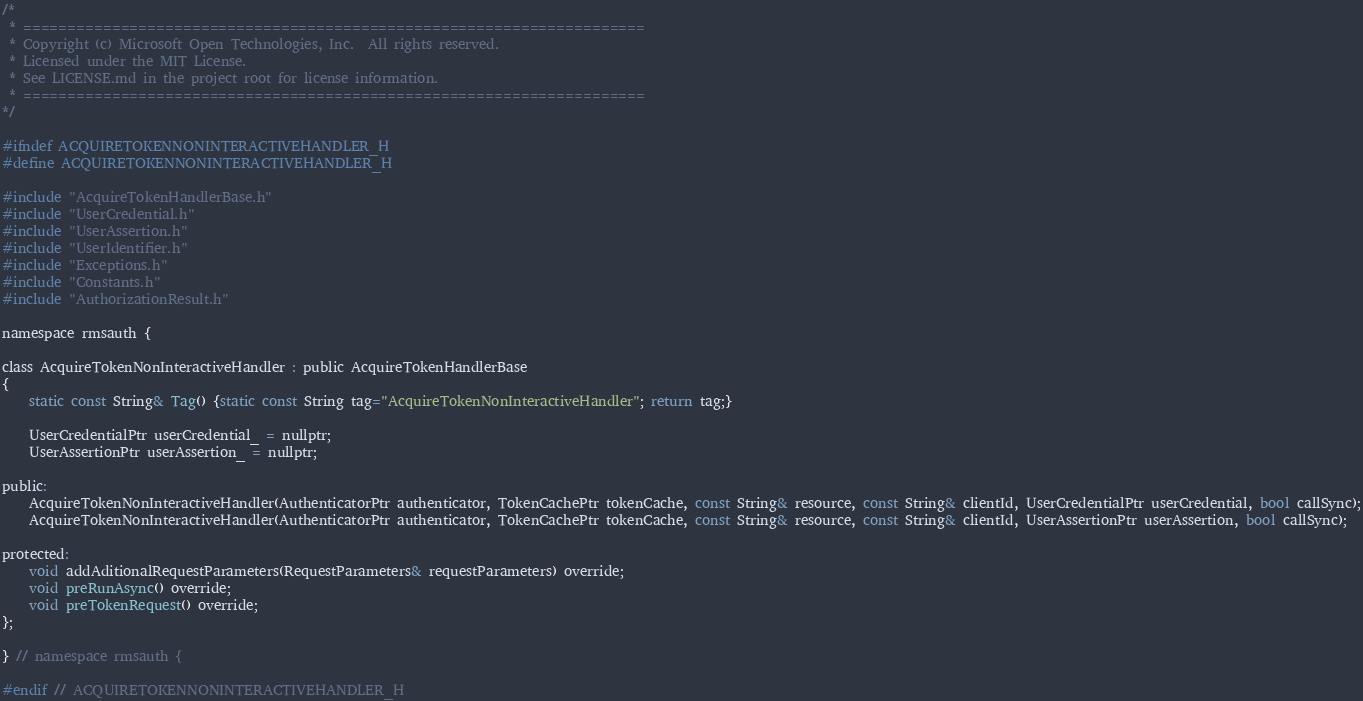<code> <loc_0><loc_0><loc_500><loc_500><_C_>/*
 * ======================================================================
 * Copyright (c) Microsoft Open Technologies, Inc.  All rights reserved.
 * Licensed under the MIT License.
 * See LICENSE.md in the project root for license information.
 * ======================================================================
*/

#ifndef ACQUIRETOKENNONINTERACTIVEHANDLER_H
#define ACQUIRETOKENNONINTERACTIVEHANDLER_H

#include "AcquireTokenHandlerBase.h"
#include "UserCredential.h"
#include "UserAssertion.h"
#include "UserIdentifier.h"
#include "Exceptions.h"
#include "Constants.h"
#include "AuthorizationResult.h"

namespace rmsauth {

class AcquireTokenNonInteractiveHandler : public AcquireTokenHandlerBase
{
    static const String& Tag() {static const String tag="AcquireTokenNonInteractiveHandler"; return tag;}

    UserCredentialPtr userCredential_ = nullptr;
    UserAssertionPtr userAssertion_ = nullptr;

public:
    AcquireTokenNonInteractiveHandler(AuthenticatorPtr authenticator, TokenCachePtr tokenCache, const String& resource, const String& clientId, UserCredentialPtr userCredential, bool callSync);
    AcquireTokenNonInteractiveHandler(AuthenticatorPtr authenticator, TokenCachePtr tokenCache, const String& resource, const String& clientId, UserAssertionPtr userAssertion, bool callSync);

protected:
    void addAditionalRequestParameters(RequestParameters& requestParameters) override;
    void preRunAsync() override;
    void preTokenRequest() override;
};

} // namespace rmsauth {

#endif // ACQUIRETOKENNONINTERACTIVEHANDLER_H
</code> 